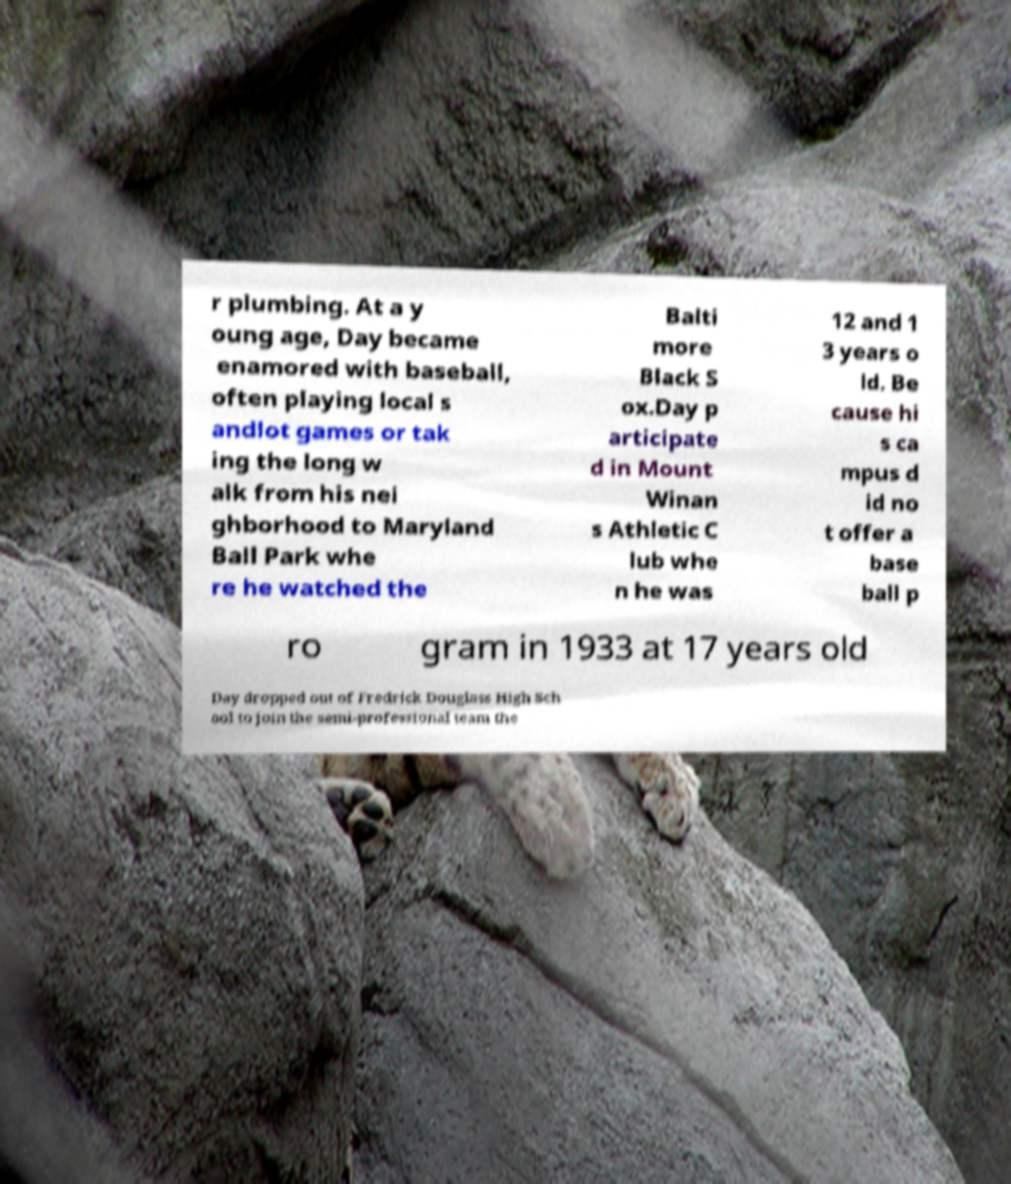Could you assist in decoding the text presented in this image and type it out clearly? r plumbing. At a y oung age, Day became enamored with baseball, often playing local s andlot games or tak ing the long w alk from his nei ghborhood to Maryland Ball Park whe re he watched the Balti more Black S ox.Day p articipate d in Mount Winan s Athletic C lub whe n he was 12 and 1 3 years o ld. Be cause hi s ca mpus d id no t offer a base ball p ro gram in 1933 at 17 years old Day dropped out of Fredrick Douglass High Sch ool to join the semi-professional team the 